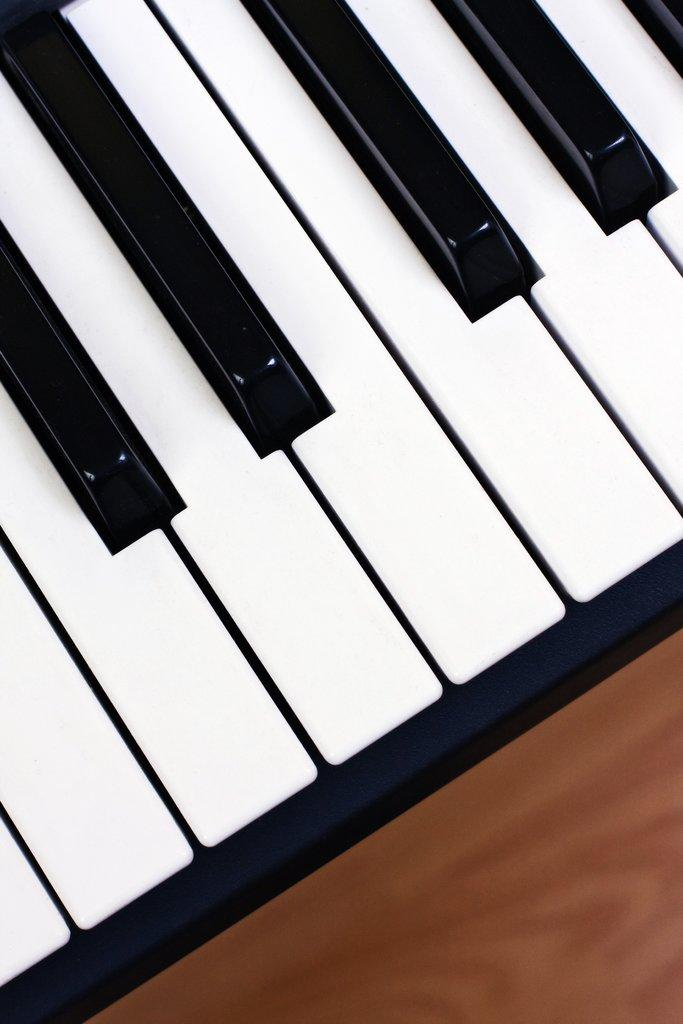What musical instrument is featured in the image? There is a piano keyboard in the image. What type of vegetable is sitting on the piano keyboard in the image? There is no vegetable present on the piano keyboard in the image. 